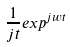<formula> <loc_0><loc_0><loc_500><loc_500>\frac { 1 } { j t } e x p ^ { j w t }</formula> 